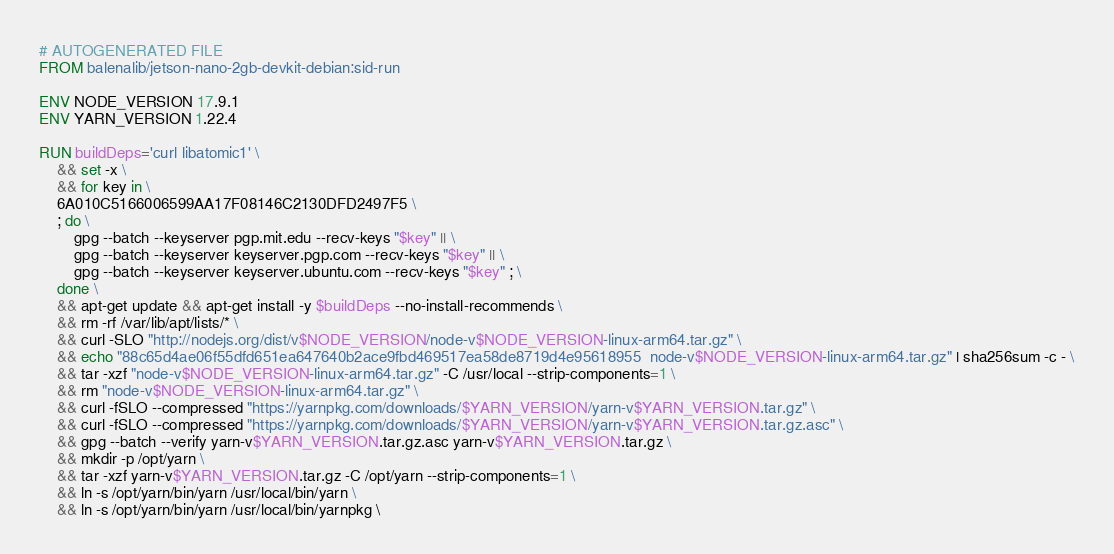<code> <loc_0><loc_0><loc_500><loc_500><_Dockerfile_># AUTOGENERATED FILE
FROM balenalib/jetson-nano-2gb-devkit-debian:sid-run

ENV NODE_VERSION 17.9.1
ENV YARN_VERSION 1.22.4

RUN buildDeps='curl libatomic1' \
	&& set -x \
	&& for key in \
	6A010C5166006599AA17F08146C2130DFD2497F5 \
	; do \
		gpg --batch --keyserver pgp.mit.edu --recv-keys "$key" || \
		gpg --batch --keyserver keyserver.pgp.com --recv-keys "$key" || \
		gpg --batch --keyserver keyserver.ubuntu.com --recv-keys "$key" ; \
	done \
	&& apt-get update && apt-get install -y $buildDeps --no-install-recommends \
	&& rm -rf /var/lib/apt/lists/* \
	&& curl -SLO "http://nodejs.org/dist/v$NODE_VERSION/node-v$NODE_VERSION-linux-arm64.tar.gz" \
	&& echo "88c65d4ae06f55dfd651ea647640b2ace9fbd469517ea58de8719d4e95618955  node-v$NODE_VERSION-linux-arm64.tar.gz" | sha256sum -c - \
	&& tar -xzf "node-v$NODE_VERSION-linux-arm64.tar.gz" -C /usr/local --strip-components=1 \
	&& rm "node-v$NODE_VERSION-linux-arm64.tar.gz" \
	&& curl -fSLO --compressed "https://yarnpkg.com/downloads/$YARN_VERSION/yarn-v$YARN_VERSION.tar.gz" \
	&& curl -fSLO --compressed "https://yarnpkg.com/downloads/$YARN_VERSION/yarn-v$YARN_VERSION.tar.gz.asc" \
	&& gpg --batch --verify yarn-v$YARN_VERSION.tar.gz.asc yarn-v$YARN_VERSION.tar.gz \
	&& mkdir -p /opt/yarn \
	&& tar -xzf yarn-v$YARN_VERSION.tar.gz -C /opt/yarn --strip-components=1 \
	&& ln -s /opt/yarn/bin/yarn /usr/local/bin/yarn \
	&& ln -s /opt/yarn/bin/yarn /usr/local/bin/yarnpkg \</code> 